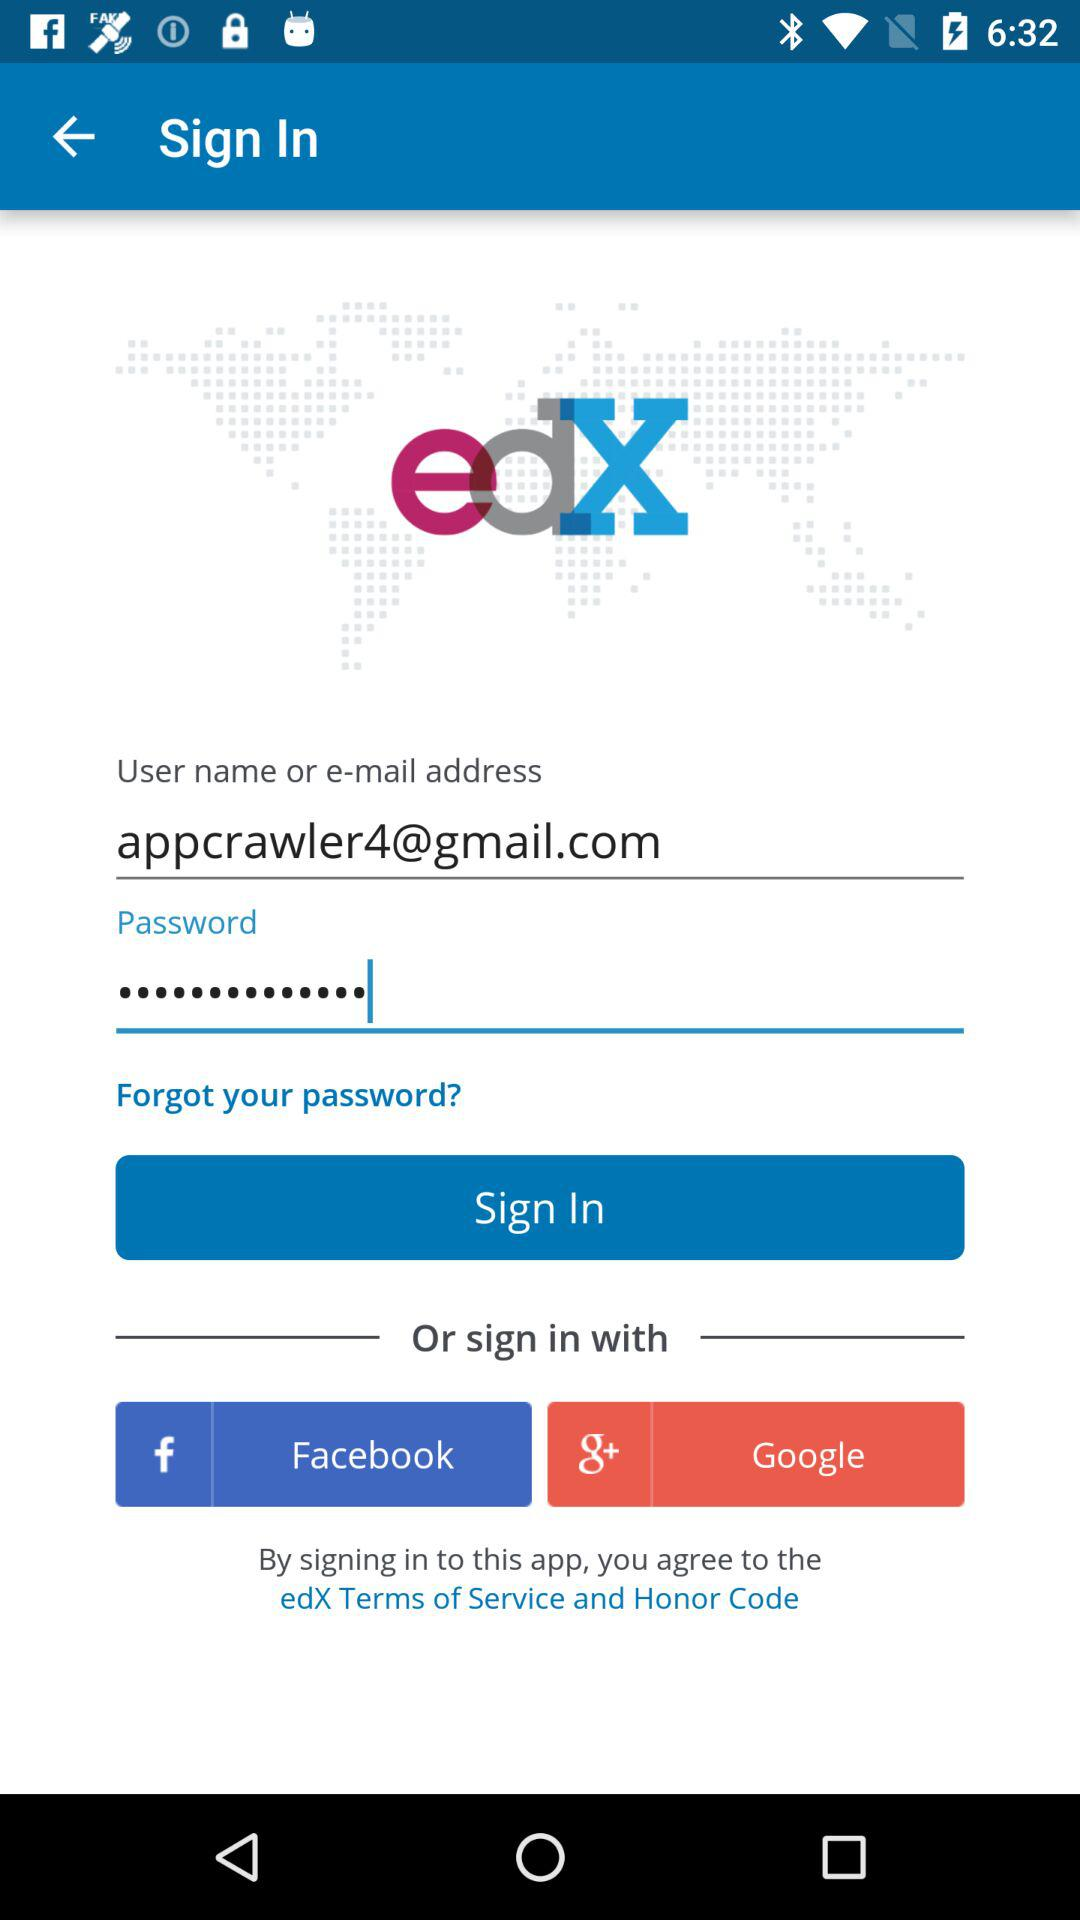What is the application name? The application name is "edX". 